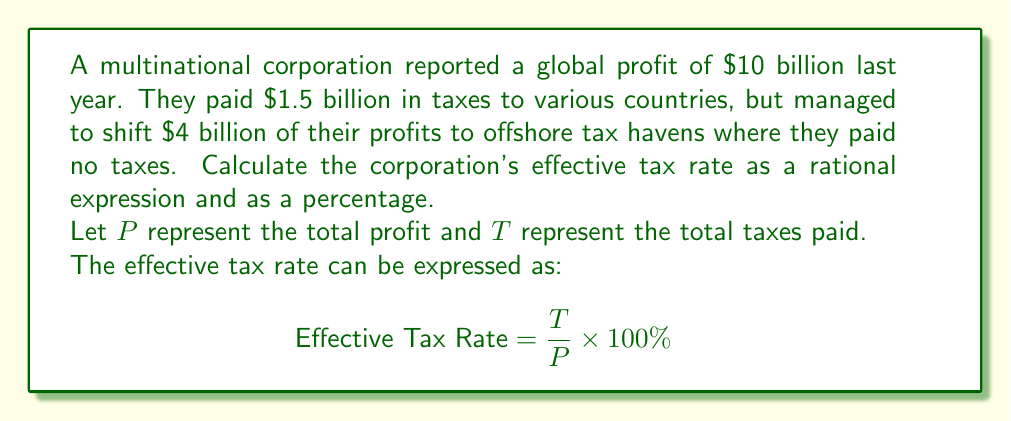Show me your answer to this math problem. 1) First, we need to determine the actual profit on which taxes were paid:
   $P_{\text{taxed}} = \text{Total Profit} - \text{Profit shifted to tax havens}$
   $P_{\text{taxed}} = 10 \text{ billion} - 4 \text{ billion} = 6 \text{ billion}$

2) Now we can set up our rational expression:
   $$\text{Effective Tax Rate} = \frac{T}{P} = \frac{1.5 \text{ billion}}{10 \text{ billion}}$$

3) Simplify the fraction:
   $$\frac{1.5}{10} = \frac{15}{100} = \frac{3}{20}$$

4) To express as a percentage, multiply by 100%:
   $$\frac{3}{20} \times 100\% = 15\%$$

5) Note that if we calculated based only on the taxed profit:
   $$\frac{1.5 \text{ billion}}{6 \text{ billion}} = \frac{1}{4} = 25\%$$
   This shows how the use of tax havens significantly reduces the effective tax rate.
Answer: $\frac{3}{20}$ or 15% 